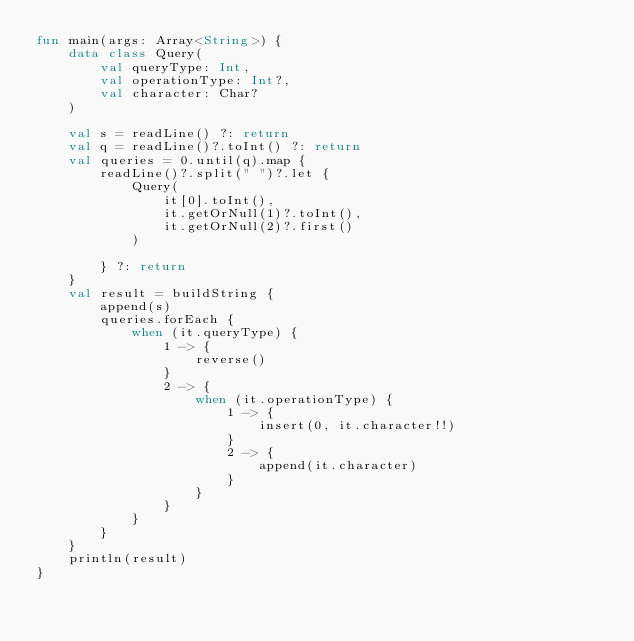<code> <loc_0><loc_0><loc_500><loc_500><_Kotlin_>fun main(args: Array<String>) {
    data class Query(
        val queryType: Int,
        val operationType: Int?,
        val character: Char?
    )

    val s = readLine() ?: return
    val q = readLine()?.toInt() ?: return
    val queries = 0.until(q).map {
        readLine()?.split(" ")?.let {
            Query(
                it[0].toInt(),
                it.getOrNull(1)?.toInt(),
                it.getOrNull(2)?.first()
            )

        } ?: return
    }
    val result = buildString {
        append(s)
        queries.forEach {
            when (it.queryType) {
                1 -> {
                    reverse()
                }
                2 -> {
                    when (it.operationType) {
                        1 -> {
                            insert(0, it.character!!)
                        }
                        2 -> {
                            append(it.character)
                        }
                    }
                }
            }
        }
    }
    println(result)
}</code> 